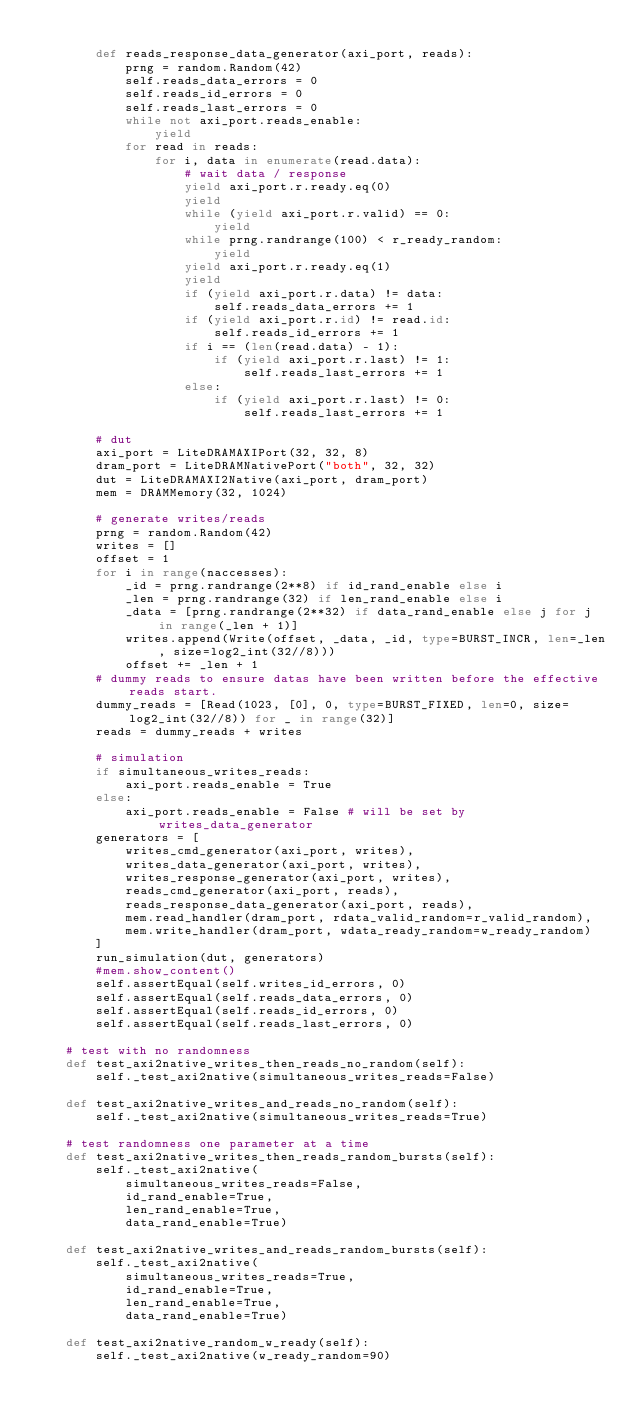Convert code to text. <code><loc_0><loc_0><loc_500><loc_500><_Python_>
        def reads_response_data_generator(axi_port, reads):
            prng = random.Random(42)
            self.reads_data_errors = 0
            self.reads_id_errors = 0
            self.reads_last_errors = 0
            while not axi_port.reads_enable:
                yield
            for read in reads:
                for i, data in enumerate(read.data):
                    # wait data / response
                    yield axi_port.r.ready.eq(0)
                    yield
                    while (yield axi_port.r.valid) == 0:
                        yield
                    while prng.randrange(100) < r_ready_random:
                        yield
                    yield axi_port.r.ready.eq(1)
                    yield
                    if (yield axi_port.r.data) != data:
                        self.reads_data_errors += 1
                    if (yield axi_port.r.id) != read.id:
                        self.reads_id_errors += 1
                    if i == (len(read.data) - 1):
                        if (yield axi_port.r.last) != 1:
                            self.reads_last_errors += 1
                    else:
                        if (yield axi_port.r.last) != 0:
                            self.reads_last_errors += 1

        # dut
        axi_port = LiteDRAMAXIPort(32, 32, 8)
        dram_port = LiteDRAMNativePort("both", 32, 32)
        dut = LiteDRAMAXI2Native(axi_port, dram_port)
        mem = DRAMMemory(32, 1024)

        # generate writes/reads
        prng = random.Random(42)
        writes = []
        offset = 1
        for i in range(naccesses):
            _id = prng.randrange(2**8) if id_rand_enable else i
            _len = prng.randrange(32) if len_rand_enable else i
            _data = [prng.randrange(2**32) if data_rand_enable else j for j in range(_len + 1)]
            writes.append(Write(offset, _data, _id, type=BURST_INCR, len=_len, size=log2_int(32//8)))
            offset += _len + 1
        # dummy reads to ensure datas have been written before the effective reads start.
        dummy_reads = [Read(1023, [0], 0, type=BURST_FIXED, len=0, size=log2_int(32//8)) for _ in range(32)]
        reads = dummy_reads + writes

        # simulation
        if simultaneous_writes_reads:
            axi_port.reads_enable = True
        else:
            axi_port.reads_enable = False # will be set by writes_data_generator
        generators = [
            writes_cmd_generator(axi_port, writes),
            writes_data_generator(axi_port, writes),
            writes_response_generator(axi_port, writes),
            reads_cmd_generator(axi_port, reads),
            reads_response_data_generator(axi_port, reads),
            mem.read_handler(dram_port, rdata_valid_random=r_valid_random),
            mem.write_handler(dram_port, wdata_ready_random=w_ready_random)
        ]
        run_simulation(dut, generators)
        #mem.show_content()
        self.assertEqual(self.writes_id_errors, 0)
        self.assertEqual(self.reads_data_errors, 0)
        self.assertEqual(self.reads_id_errors, 0)
        self.assertEqual(self.reads_last_errors, 0)

    # test with no randomness
    def test_axi2native_writes_then_reads_no_random(self):
        self._test_axi2native(simultaneous_writes_reads=False)

    def test_axi2native_writes_and_reads_no_random(self):
        self._test_axi2native(simultaneous_writes_reads=True)

    # test randomness one parameter at a time
    def test_axi2native_writes_then_reads_random_bursts(self):
        self._test_axi2native(
            simultaneous_writes_reads=False,
            id_rand_enable=True,
            len_rand_enable=True,
            data_rand_enable=True)

    def test_axi2native_writes_and_reads_random_bursts(self):
        self._test_axi2native(
            simultaneous_writes_reads=True,
            id_rand_enable=True,
            len_rand_enable=True,
            data_rand_enable=True)

    def test_axi2native_random_w_ready(self):
        self._test_axi2native(w_ready_random=90)
</code> 